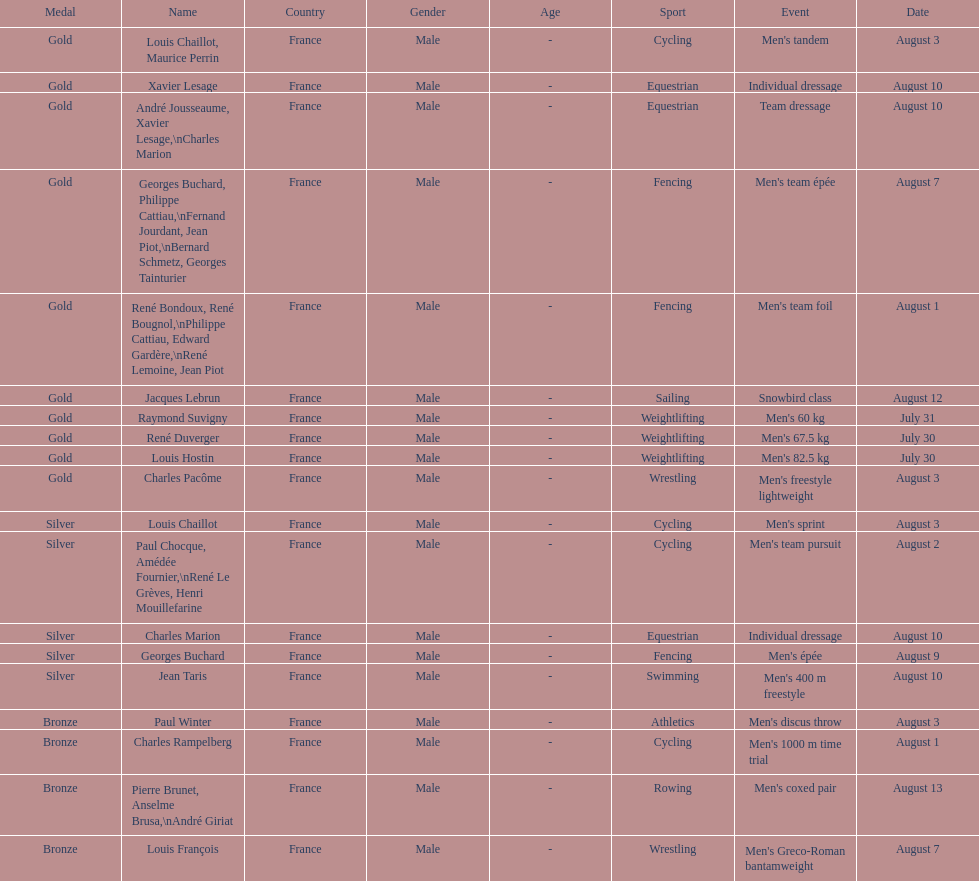What is next date that is listed after august 7th? August 1. 